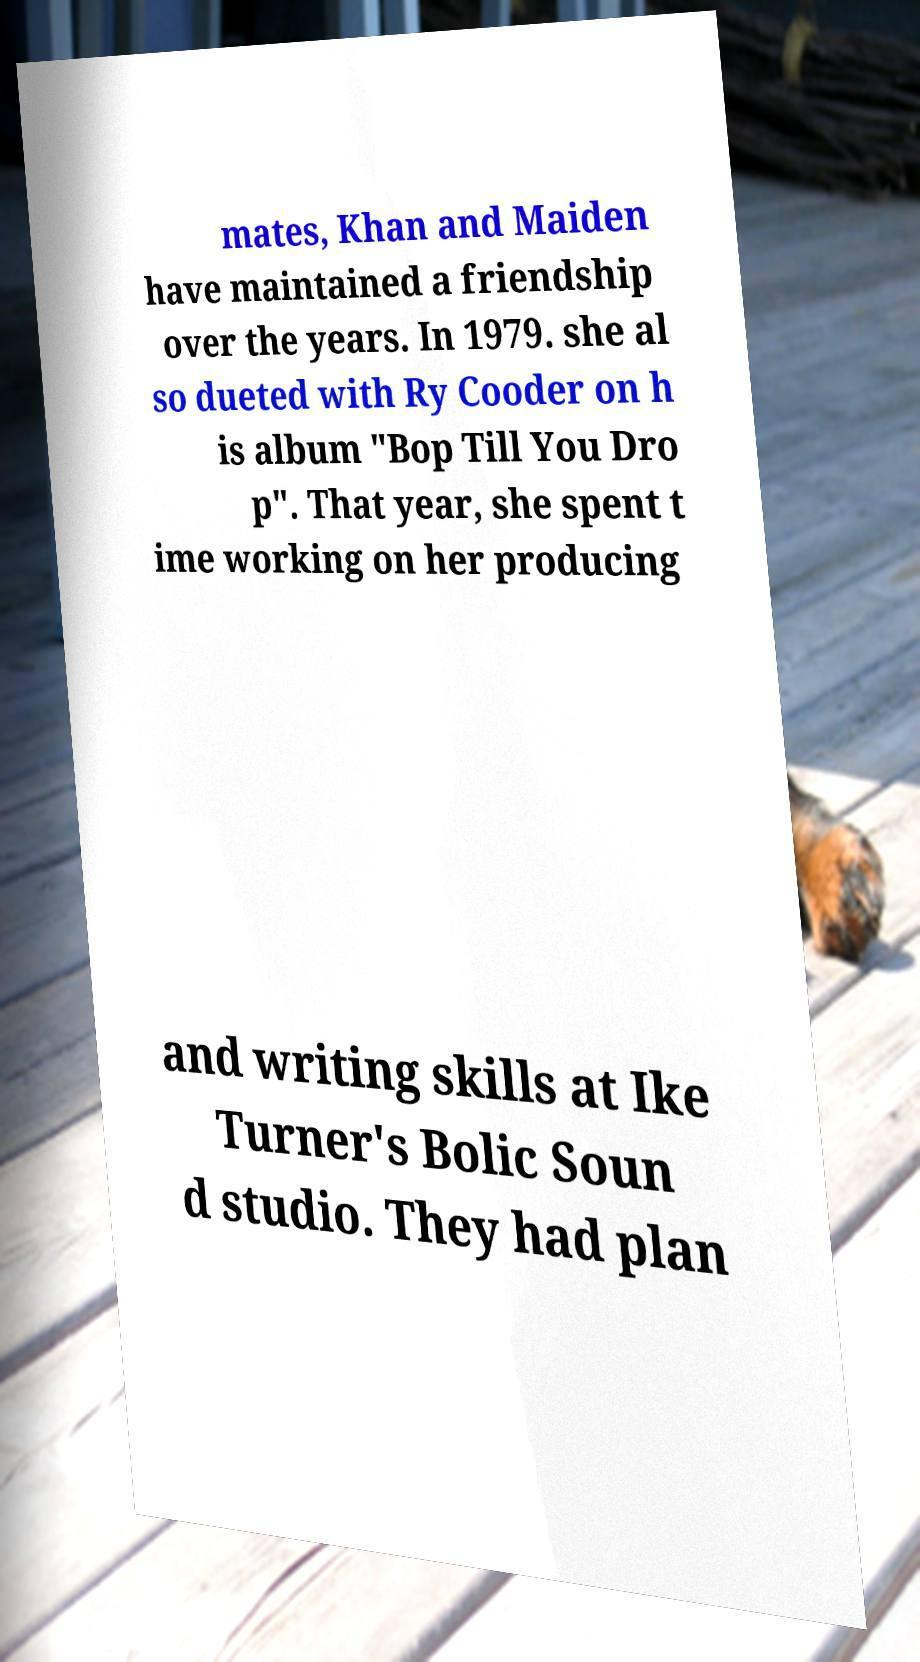What messages or text are displayed in this image? I need them in a readable, typed format. mates, Khan and Maiden have maintained a friendship over the years. In 1979. she al so dueted with Ry Cooder on h is album "Bop Till You Dro p". That year, she spent t ime working on her producing and writing skills at Ike Turner's Bolic Soun d studio. They had plan 